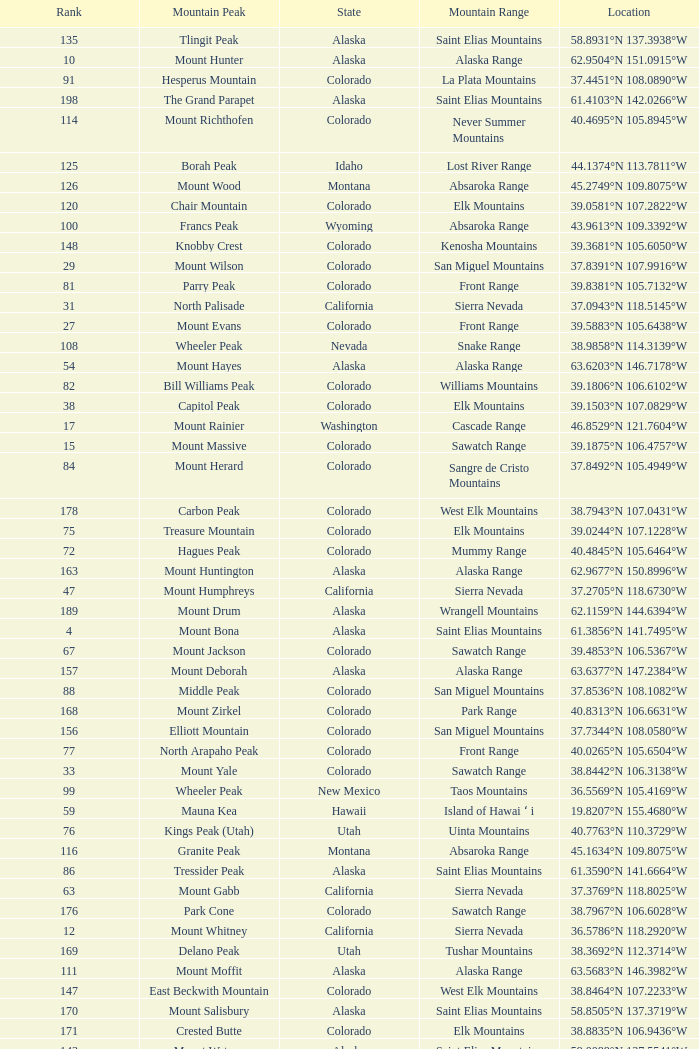What is the mountain peak when the location is 37.5775°n 105.4856°w? Blanca Peak. 